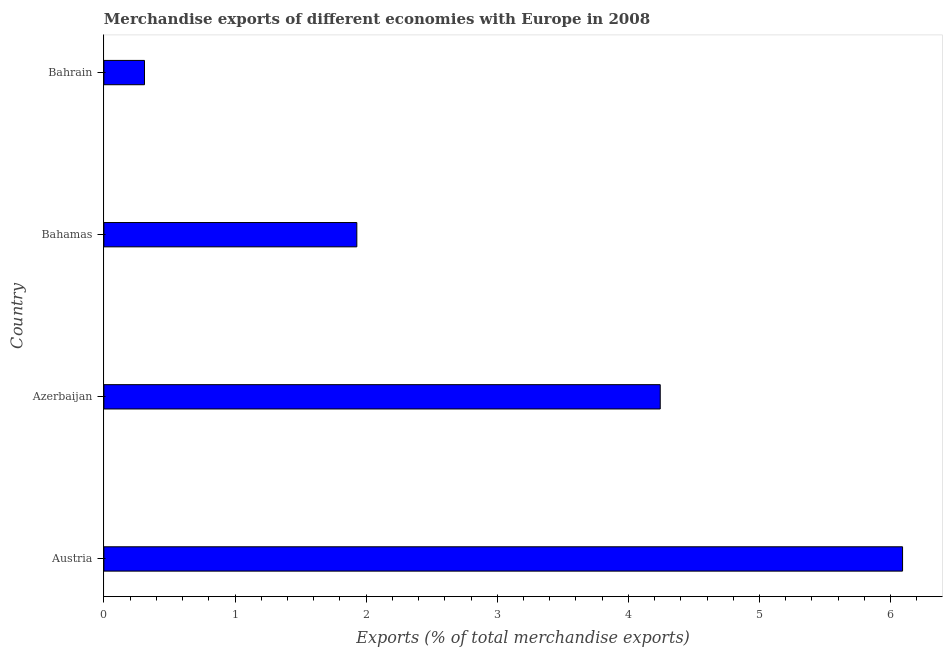What is the title of the graph?
Provide a succinct answer. Merchandise exports of different economies with Europe in 2008. What is the label or title of the X-axis?
Give a very brief answer. Exports (% of total merchandise exports). What is the label or title of the Y-axis?
Provide a succinct answer. Country. What is the merchandise exports in Bahrain?
Offer a terse response. 0.31. Across all countries, what is the maximum merchandise exports?
Give a very brief answer. 6.09. Across all countries, what is the minimum merchandise exports?
Provide a short and direct response. 0.31. In which country was the merchandise exports minimum?
Provide a succinct answer. Bahrain. What is the sum of the merchandise exports?
Your answer should be compact. 12.57. What is the difference between the merchandise exports in Austria and Bahamas?
Offer a terse response. 4.16. What is the average merchandise exports per country?
Ensure brevity in your answer.  3.14. What is the median merchandise exports?
Offer a very short reply. 3.09. What is the ratio of the merchandise exports in Austria to that in Azerbaijan?
Provide a succinct answer. 1.44. Is the difference between the merchandise exports in Azerbaijan and Bahamas greater than the difference between any two countries?
Keep it short and to the point. No. What is the difference between the highest and the second highest merchandise exports?
Provide a short and direct response. 1.85. What is the difference between the highest and the lowest merchandise exports?
Make the answer very short. 5.78. How many bars are there?
Offer a very short reply. 4. What is the difference between two consecutive major ticks on the X-axis?
Ensure brevity in your answer.  1. What is the Exports (% of total merchandise exports) of Austria?
Offer a terse response. 6.09. What is the Exports (% of total merchandise exports) in Azerbaijan?
Your answer should be very brief. 4.24. What is the Exports (% of total merchandise exports) of Bahamas?
Ensure brevity in your answer.  1.93. What is the Exports (% of total merchandise exports) of Bahrain?
Ensure brevity in your answer.  0.31. What is the difference between the Exports (% of total merchandise exports) in Austria and Azerbaijan?
Provide a short and direct response. 1.85. What is the difference between the Exports (% of total merchandise exports) in Austria and Bahamas?
Give a very brief answer. 4.16. What is the difference between the Exports (% of total merchandise exports) in Austria and Bahrain?
Your answer should be compact. 5.78. What is the difference between the Exports (% of total merchandise exports) in Azerbaijan and Bahamas?
Offer a terse response. 2.31. What is the difference between the Exports (% of total merchandise exports) in Azerbaijan and Bahrain?
Make the answer very short. 3.93. What is the difference between the Exports (% of total merchandise exports) in Bahamas and Bahrain?
Provide a short and direct response. 1.62. What is the ratio of the Exports (% of total merchandise exports) in Austria to that in Azerbaijan?
Make the answer very short. 1.44. What is the ratio of the Exports (% of total merchandise exports) in Austria to that in Bahamas?
Give a very brief answer. 3.16. What is the ratio of the Exports (% of total merchandise exports) in Austria to that in Bahrain?
Make the answer very short. 19.67. What is the ratio of the Exports (% of total merchandise exports) in Azerbaijan to that in Bahamas?
Offer a terse response. 2.2. What is the ratio of the Exports (% of total merchandise exports) in Azerbaijan to that in Bahrain?
Offer a very short reply. 13.7. What is the ratio of the Exports (% of total merchandise exports) in Bahamas to that in Bahrain?
Your response must be concise. 6.23. 